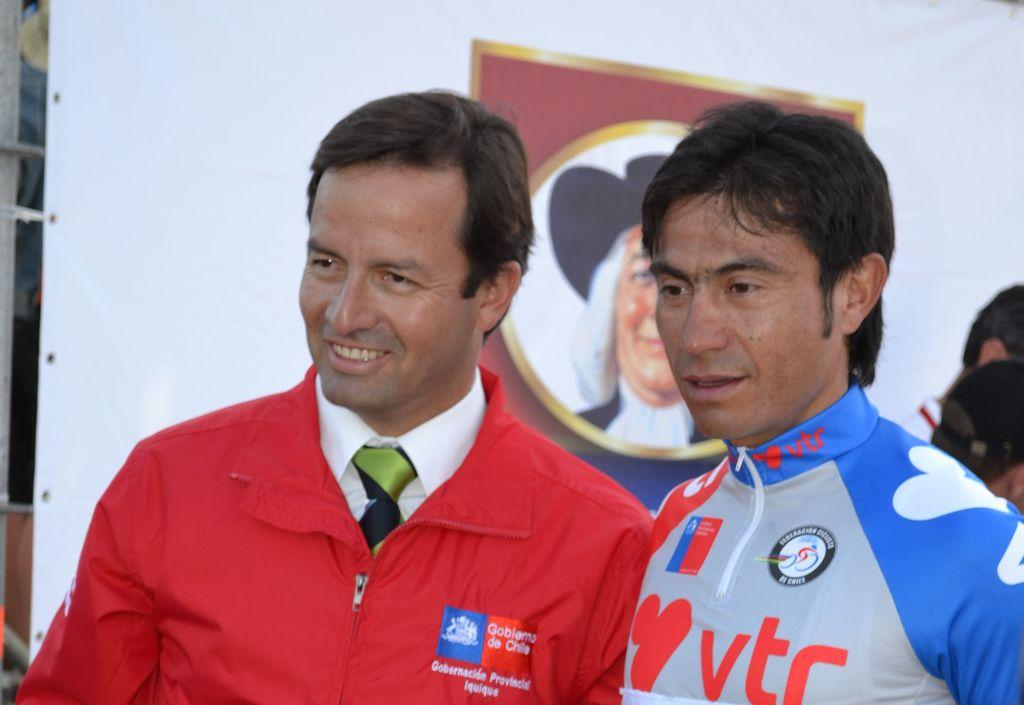<image>
Offer a succinct explanation of the picture presented. a man with a blue and gray shirt with TR on it 